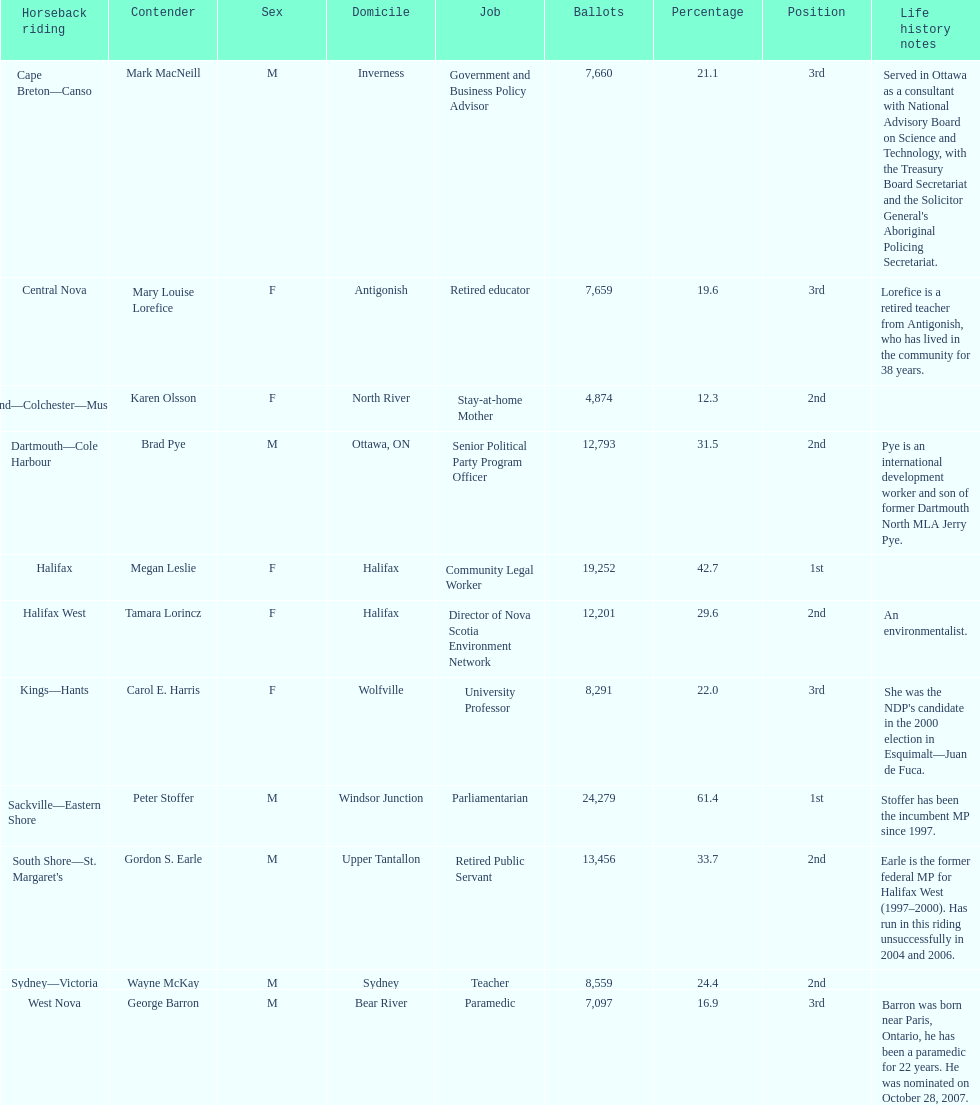Who garnered more votes, macneill or olsson? Mark MacNeill. 